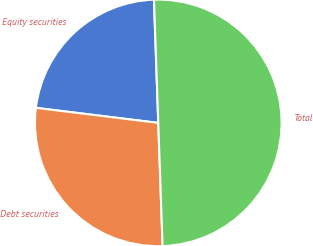<chart> <loc_0><loc_0><loc_500><loc_500><pie_chart><fcel>Equity securities<fcel>Debt securities<fcel>Total<nl><fcel>22.5%<fcel>27.5%<fcel>50.0%<nl></chart> 